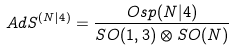Convert formula to latex. <formula><loc_0><loc_0><loc_500><loc_500>A d S ^ { ( N | 4 ) } = \frac { O s p ( N | 4 ) } { S O ( 1 , 3 ) \otimes S O ( N ) }</formula> 